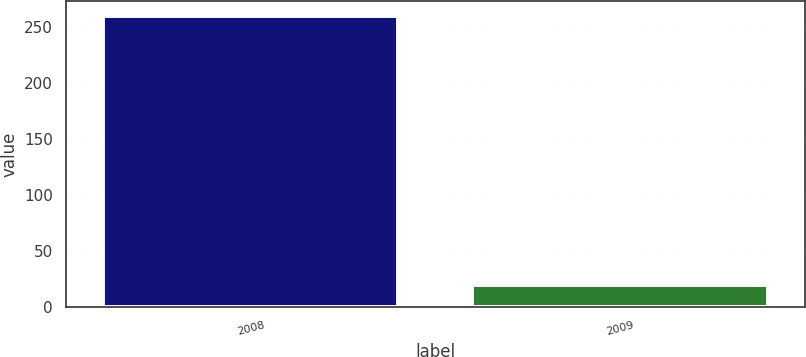Convert chart to OTSL. <chart><loc_0><loc_0><loc_500><loc_500><bar_chart><fcel>2008<fcel>2009<nl><fcel>260<fcel>20<nl></chart> 